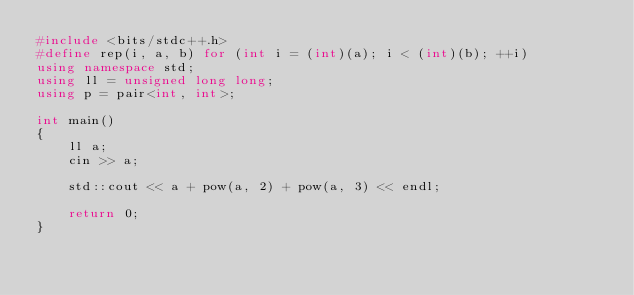Convert code to text. <code><loc_0><loc_0><loc_500><loc_500><_C++_>#include <bits/stdc++.h>
#define rep(i, a, b) for (int i = (int)(a); i < (int)(b); ++i)
using namespace std;
using ll = unsigned long long;
using p = pair<int, int>;

int main()
{
    ll a;
    cin >> a;

    std::cout << a + pow(a, 2) + pow(a, 3) << endl;

    return 0;
}</code> 